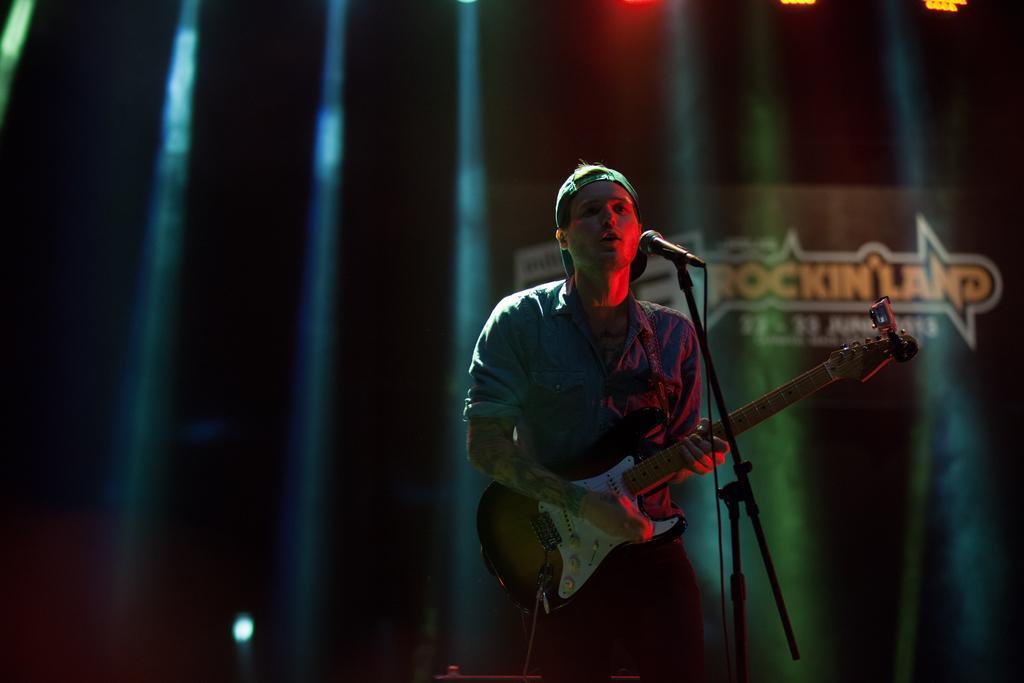How would you summarize this image in a sentence or two? In this image I can see a man is standing and playing the guitar and also singing in the microphone. He wore shirt, cap, on the right side there is the name in yellow color. 